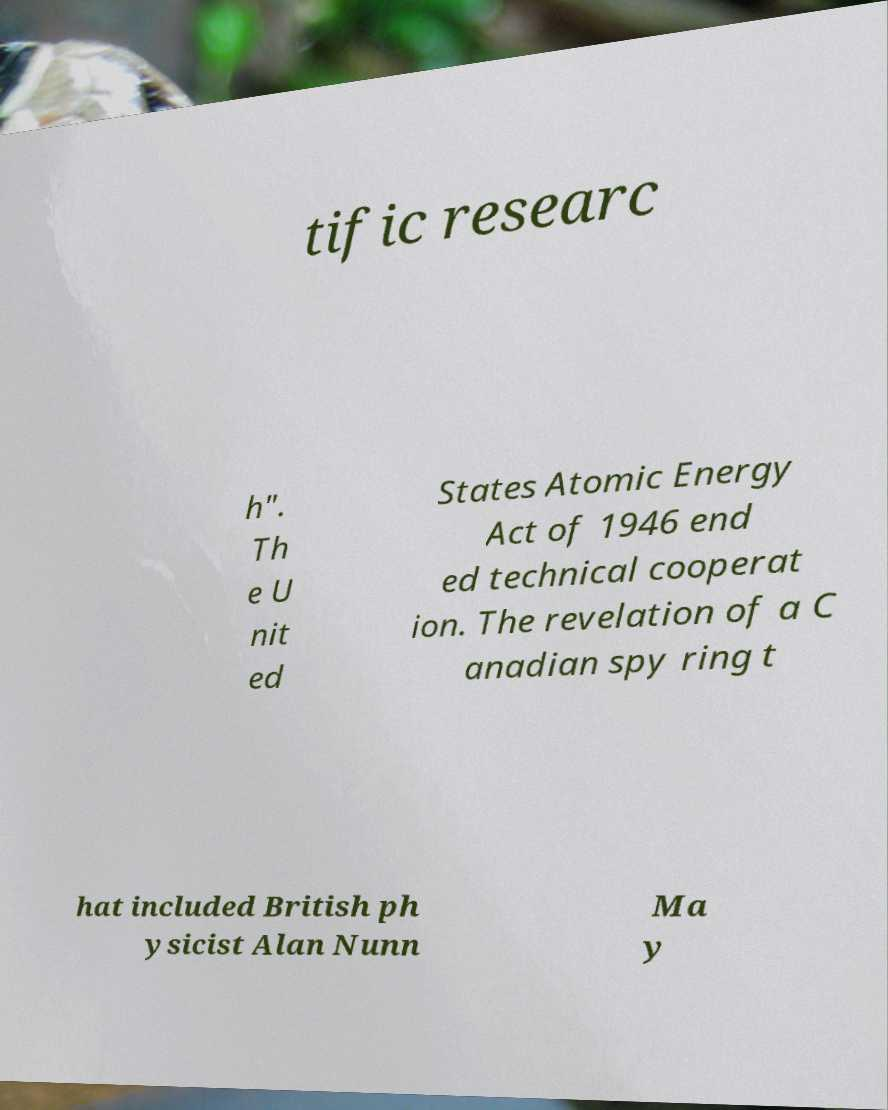Could you extract and type out the text from this image? tific researc h". Th e U nit ed States Atomic Energy Act of 1946 end ed technical cooperat ion. The revelation of a C anadian spy ring t hat included British ph ysicist Alan Nunn Ma y 